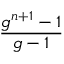Convert formula to latex. <formula><loc_0><loc_0><loc_500><loc_500>\frac { g ^ { n + 1 } - 1 } { g - 1 }</formula> 